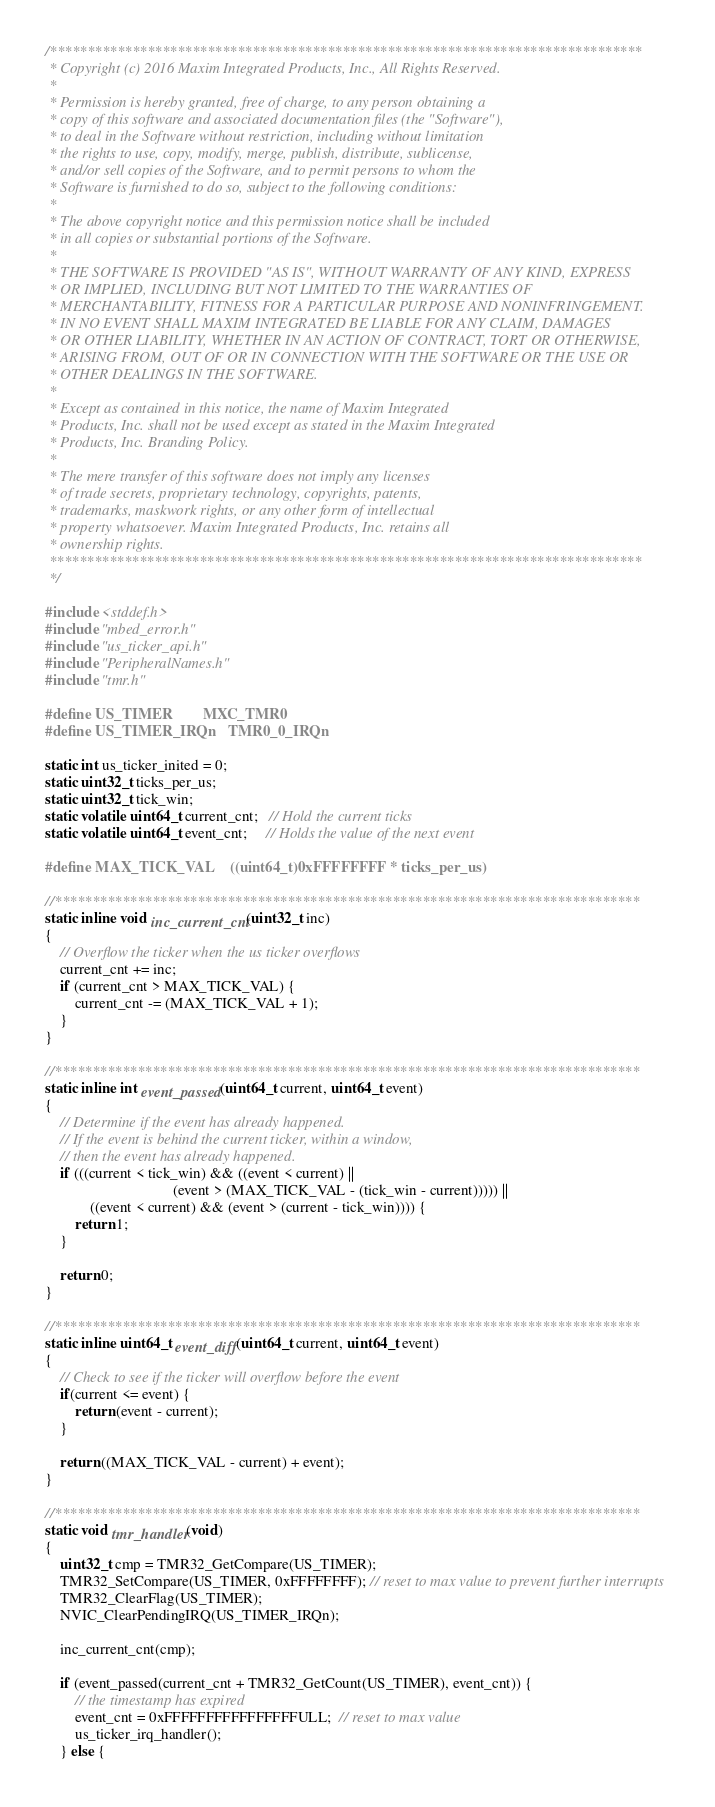<code> <loc_0><loc_0><loc_500><loc_500><_C_>/*******************************************************************************
 * Copyright (c) 2016 Maxim Integrated Products, Inc., All Rights Reserved.
 *
 * Permission is hereby granted, free of charge, to any person obtaining a
 * copy of this software and associated documentation files (the "Software"),
 * to deal in the Software without restriction, including without limitation
 * the rights to use, copy, modify, merge, publish, distribute, sublicense,
 * and/or sell copies of the Software, and to permit persons to whom the
 * Software is furnished to do so, subject to the following conditions:
 *
 * The above copyright notice and this permission notice shall be included
 * in all copies or substantial portions of the Software.
 *
 * THE SOFTWARE IS PROVIDED "AS IS", WITHOUT WARRANTY OF ANY KIND, EXPRESS
 * OR IMPLIED, INCLUDING BUT NOT LIMITED TO THE WARRANTIES OF
 * MERCHANTABILITY, FITNESS FOR A PARTICULAR PURPOSE AND NONINFRINGEMENT.
 * IN NO EVENT SHALL MAXIM INTEGRATED BE LIABLE FOR ANY CLAIM, DAMAGES
 * OR OTHER LIABILITY, WHETHER IN AN ACTION OF CONTRACT, TORT OR OTHERWISE,
 * ARISING FROM, OUT OF OR IN CONNECTION WITH THE SOFTWARE OR THE USE OR
 * OTHER DEALINGS IN THE SOFTWARE.
 *
 * Except as contained in this notice, the name of Maxim Integrated
 * Products, Inc. shall not be used except as stated in the Maxim Integrated
 * Products, Inc. Branding Policy.
 *
 * The mere transfer of this software does not imply any licenses
 * of trade secrets, proprietary technology, copyrights, patents,
 * trademarks, maskwork rights, or any other form of intellectual
 * property whatsoever. Maxim Integrated Products, Inc. retains all
 * ownership rights.
 *******************************************************************************
 */

#include <stddef.h>
#include "mbed_error.h"
#include "us_ticker_api.h"
#include "PeripheralNames.h"
#include "tmr.h"

#define US_TIMER        MXC_TMR0
#define US_TIMER_IRQn   TMR0_0_IRQn

static int us_ticker_inited = 0;
static uint32_t ticks_per_us;
static uint32_t tick_win;
static volatile uint64_t current_cnt;   // Hold the current ticks
static volatile uint64_t event_cnt;     // Holds the value of the next event

#define MAX_TICK_VAL    ((uint64_t)0xFFFFFFFF * ticks_per_us)

//******************************************************************************
static inline void inc_current_cnt(uint32_t inc)
{
    // Overflow the ticker when the us ticker overflows
    current_cnt += inc;
    if (current_cnt > MAX_TICK_VAL) {
        current_cnt -= (MAX_TICK_VAL + 1);
    }
}

//******************************************************************************
static inline int event_passed(uint64_t current, uint64_t event)
{
    // Determine if the event has already happened.
    // If the event is behind the current ticker, within a window,
    // then the event has already happened.
    if (((current < tick_win) && ((event < current) ||
                                  (event > (MAX_TICK_VAL - (tick_win - current))))) ||
            ((event < current) && (event > (current - tick_win)))) {
        return 1;
    }

    return 0;
}

//******************************************************************************
static inline uint64_t event_diff(uint64_t current, uint64_t event)
{
    // Check to see if the ticker will overflow before the event
    if(current <= event) {
        return (event - current);
    }

    return ((MAX_TICK_VAL - current) + event);
}

//******************************************************************************
static void tmr_handler(void)
{
    uint32_t cmp = TMR32_GetCompare(US_TIMER);
    TMR32_SetCompare(US_TIMER, 0xFFFFFFFF); // reset to max value to prevent further interrupts
    TMR32_ClearFlag(US_TIMER);
    NVIC_ClearPendingIRQ(US_TIMER_IRQn);

    inc_current_cnt(cmp);

    if (event_passed(current_cnt + TMR32_GetCount(US_TIMER), event_cnt)) {
        // the timestamp has expired
        event_cnt = 0xFFFFFFFFFFFFFFFFULL;  // reset to max value
        us_ticker_irq_handler();
    } else {</code> 